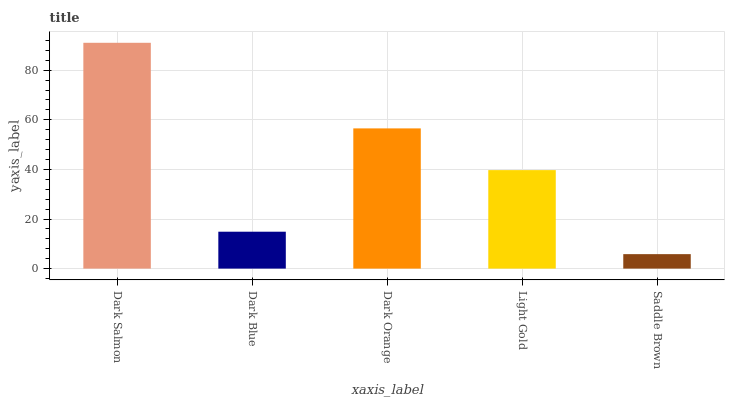Is Saddle Brown the minimum?
Answer yes or no. Yes. Is Dark Salmon the maximum?
Answer yes or no. Yes. Is Dark Blue the minimum?
Answer yes or no. No. Is Dark Blue the maximum?
Answer yes or no. No. Is Dark Salmon greater than Dark Blue?
Answer yes or no. Yes. Is Dark Blue less than Dark Salmon?
Answer yes or no. Yes. Is Dark Blue greater than Dark Salmon?
Answer yes or no. No. Is Dark Salmon less than Dark Blue?
Answer yes or no. No. Is Light Gold the high median?
Answer yes or no. Yes. Is Light Gold the low median?
Answer yes or no. Yes. Is Dark Orange the high median?
Answer yes or no. No. Is Dark Orange the low median?
Answer yes or no. No. 